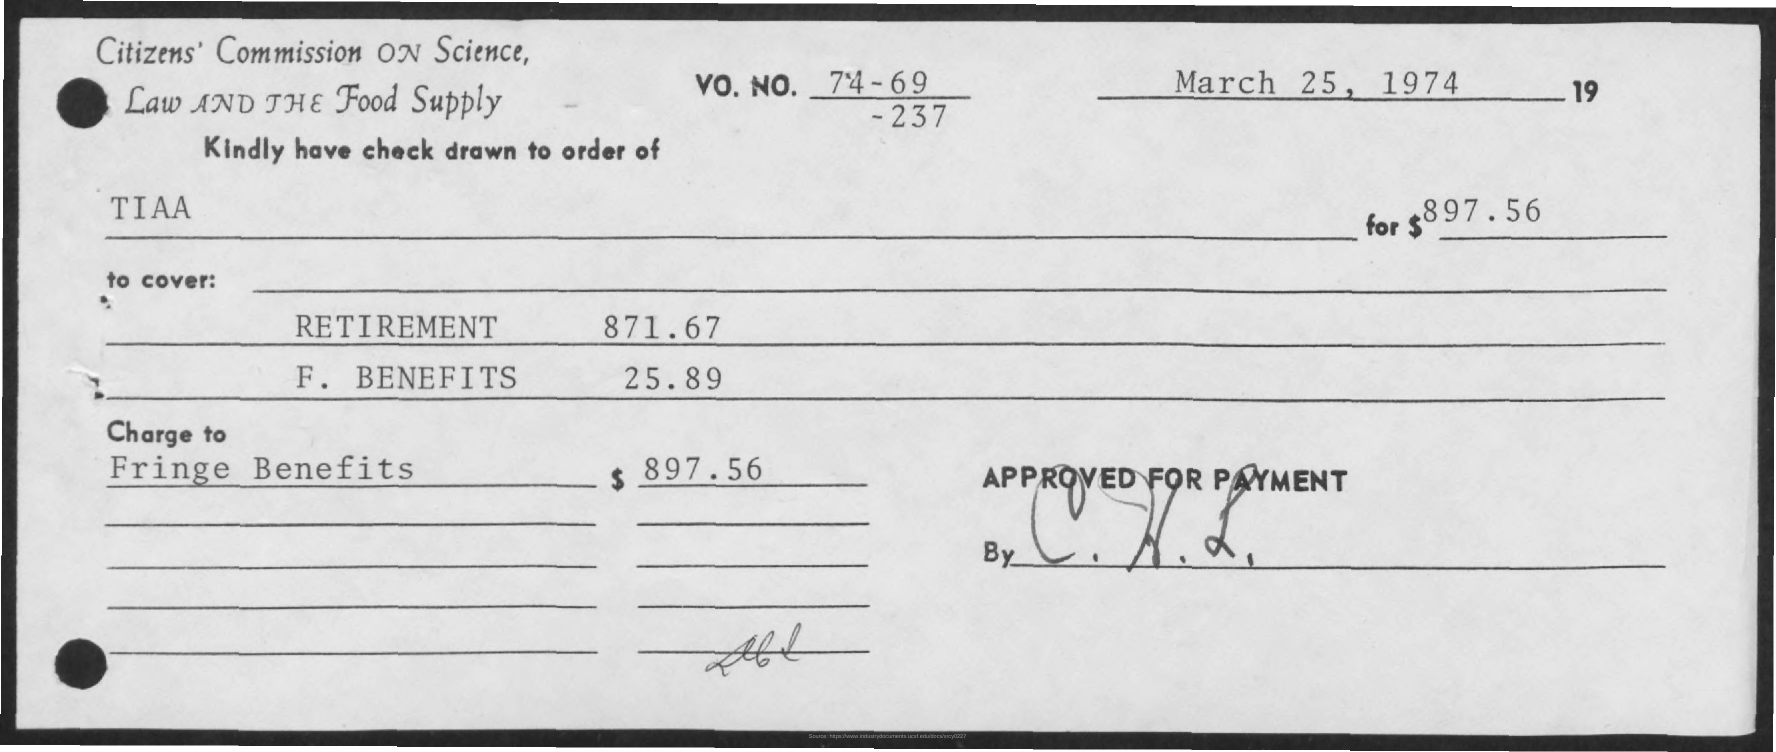What is the amount mentioned in the given check ?
Ensure brevity in your answer.  $ 897.56. What is the amount given for retirement as mentioned in the given page ?
Your answer should be compact. 871.67. What is the amount given for f.benefits in the given page ?
Give a very brief answer. 25.89. 